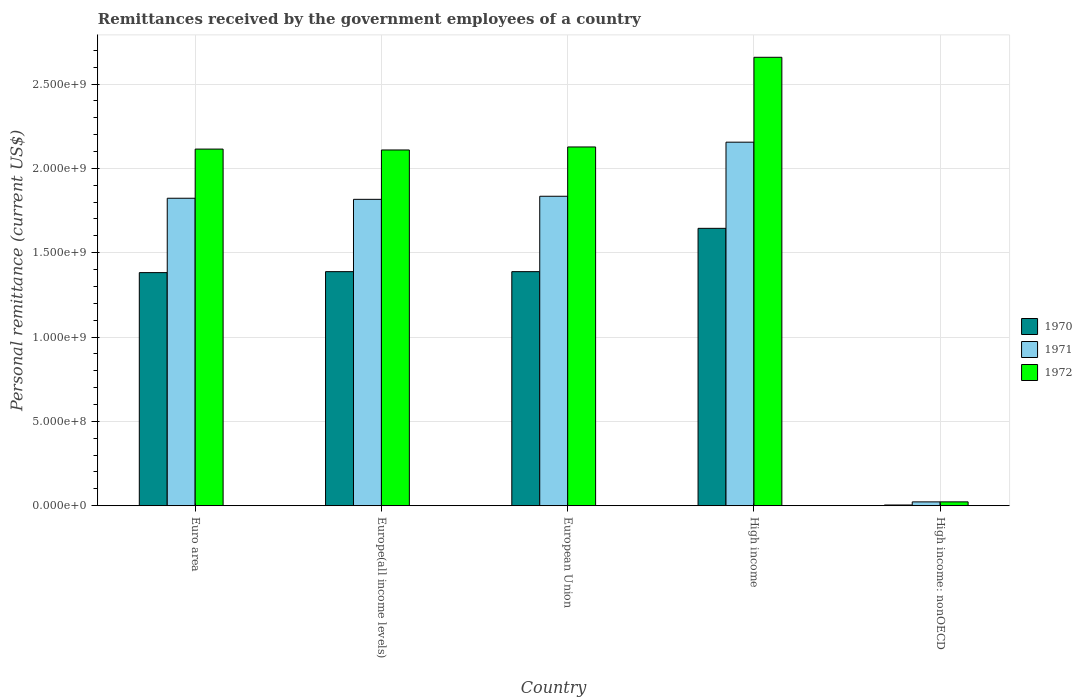How many different coloured bars are there?
Offer a very short reply. 3. How many groups of bars are there?
Your answer should be very brief. 5. Are the number of bars per tick equal to the number of legend labels?
Keep it short and to the point. Yes. How many bars are there on the 3rd tick from the left?
Make the answer very short. 3. How many bars are there on the 4th tick from the right?
Your response must be concise. 3. What is the label of the 2nd group of bars from the left?
Offer a terse response. Europe(all income levels). What is the remittances received by the government employees in 1970 in Euro area?
Provide a short and direct response. 1.38e+09. Across all countries, what is the maximum remittances received by the government employees in 1970?
Give a very brief answer. 1.64e+09. Across all countries, what is the minimum remittances received by the government employees in 1971?
Make the answer very short. 2.28e+07. In which country was the remittances received by the government employees in 1970 maximum?
Ensure brevity in your answer.  High income. In which country was the remittances received by the government employees in 1972 minimum?
Keep it short and to the point. High income: nonOECD. What is the total remittances received by the government employees in 1970 in the graph?
Your answer should be very brief. 5.81e+09. What is the difference between the remittances received by the government employees in 1970 in Europe(all income levels) and that in High income: nonOECD?
Give a very brief answer. 1.38e+09. What is the difference between the remittances received by the government employees in 1970 in High income and the remittances received by the government employees in 1972 in Euro area?
Your answer should be compact. -4.70e+08. What is the average remittances received by the government employees in 1971 per country?
Offer a terse response. 1.53e+09. What is the difference between the remittances received by the government employees of/in 1972 and remittances received by the government employees of/in 1971 in Euro area?
Your response must be concise. 2.91e+08. What is the ratio of the remittances received by the government employees in 1971 in Europe(all income levels) to that in High income: nonOECD?
Your response must be concise. 79.73. Is the difference between the remittances received by the government employees in 1972 in Euro area and European Union greater than the difference between the remittances received by the government employees in 1971 in Euro area and European Union?
Give a very brief answer. No. What is the difference between the highest and the second highest remittances received by the government employees in 1971?
Give a very brief answer. -1.17e+07. What is the difference between the highest and the lowest remittances received by the government employees in 1972?
Offer a terse response. 2.64e+09. In how many countries, is the remittances received by the government employees in 1970 greater than the average remittances received by the government employees in 1970 taken over all countries?
Make the answer very short. 4. Is the sum of the remittances received by the government employees in 1970 in European Union and High income: nonOECD greater than the maximum remittances received by the government employees in 1972 across all countries?
Give a very brief answer. No. Is it the case that in every country, the sum of the remittances received by the government employees in 1972 and remittances received by the government employees in 1971 is greater than the remittances received by the government employees in 1970?
Give a very brief answer. Yes. How many bars are there?
Provide a short and direct response. 15. Are all the bars in the graph horizontal?
Your response must be concise. No. Does the graph contain any zero values?
Provide a short and direct response. No. Where does the legend appear in the graph?
Make the answer very short. Center right. How many legend labels are there?
Your response must be concise. 3. What is the title of the graph?
Offer a very short reply. Remittances received by the government employees of a country. What is the label or title of the Y-axis?
Offer a very short reply. Personal remittance (current US$). What is the Personal remittance (current US$) in 1970 in Euro area?
Make the answer very short. 1.38e+09. What is the Personal remittance (current US$) in 1971 in Euro area?
Your answer should be very brief. 1.82e+09. What is the Personal remittance (current US$) in 1972 in Euro area?
Offer a very short reply. 2.11e+09. What is the Personal remittance (current US$) of 1970 in Europe(all income levels)?
Your response must be concise. 1.39e+09. What is the Personal remittance (current US$) in 1971 in Europe(all income levels)?
Ensure brevity in your answer.  1.82e+09. What is the Personal remittance (current US$) in 1972 in Europe(all income levels)?
Your response must be concise. 2.11e+09. What is the Personal remittance (current US$) in 1970 in European Union?
Your response must be concise. 1.39e+09. What is the Personal remittance (current US$) in 1971 in European Union?
Offer a terse response. 1.83e+09. What is the Personal remittance (current US$) in 1972 in European Union?
Make the answer very short. 2.13e+09. What is the Personal remittance (current US$) of 1970 in High income?
Ensure brevity in your answer.  1.64e+09. What is the Personal remittance (current US$) of 1971 in High income?
Offer a terse response. 2.16e+09. What is the Personal remittance (current US$) of 1972 in High income?
Offer a terse response. 2.66e+09. What is the Personal remittance (current US$) in 1970 in High income: nonOECD?
Provide a short and direct response. 4.40e+06. What is the Personal remittance (current US$) of 1971 in High income: nonOECD?
Your response must be concise. 2.28e+07. What is the Personal remittance (current US$) of 1972 in High income: nonOECD?
Provide a succinct answer. 2.29e+07. Across all countries, what is the maximum Personal remittance (current US$) of 1970?
Offer a terse response. 1.64e+09. Across all countries, what is the maximum Personal remittance (current US$) in 1971?
Offer a terse response. 2.16e+09. Across all countries, what is the maximum Personal remittance (current US$) of 1972?
Offer a terse response. 2.66e+09. Across all countries, what is the minimum Personal remittance (current US$) in 1970?
Ensure brevity in your answer.  4.40e+06. Across all countries, what is the minimum Personal remittance (current US$) in 1971?
Make the answer very short. 2.28e+07. Across all countries, what is the minimum Personal remittance (current US$) of 1972?
Give a very brief answer. 2.29e+07. What is the total Personal remittance (current US$) in 1970 in the graph?
Give a very brief answer. 5.81e+09. What is the total Personal remittance (current US$) of 1971 in the graph?
Ensure brevity in your answer.  7.65e+09. What is the total Personal remittance (current US$) in 1972 in the graph?
Provide a succinct answer. 9.03e+09. What is the difference between the Personal remittance (current US$) of 1970 in Euro area and that in Europe(all income levels)?
Offer a terse response. -5.80e+06. What is the difference between the Personal remittance (current US$) in 1971 in Euro area and that in Europe(all income levels)?
Make the answer very short. 6.47e+06. What is the difference between the Personal remittance (current US$) of 1972 in Euro area and that in Europe(all income levels)?
Give a very brief answer. 5.22e+06. What is the difference between the Personal remittance (current US$) of 1970 in Euro area and that in European Union?
Ensure brevity in your answer.  -5.80e+06. What is the difference between the Personal remittance (current US$) in 1971 in Euro area and that in European Union?
Your response must be concise. -1.17e+07. What is the difference between the Personal remittance (current US$) of 1972 in Euro area and that in European Union?
Ensure brevity in your answer.  -1.26e+07. What is the difference between the Personal remittance (current US$) in 1970 in Euro area and that in High income?
Keep it short and to the point. -2.63e+08. What is the difference between the Personal remittance (current US$) of 1971 in Euro area and that in High income?
Ensure brevity in your answer.  -3.32e+08. What is the difference between the Personal remittance (current US$) in 1972 in Euro area and that in High income?
Your answer should be compact. -5.44e+08. What is the difference between the Personal remittance (current US$) of 1970 in Euro area and that in High income: nonOECD?
Ensure brevity in your answer.  1.38e+09. What is the difference between the Personal remittance (current US$) of 1971 in Euro area and that in High income: nonOECD?
Offer a very short reply. 1.80e+09. What is the difference between the Personal remittance (current US$) in 1972 in Euro area and that in High income: nonOECD?
Keep it short and to the point. 2.09e+09. What is the difference between the Personal remittance (current US$) of 1970 in Europe(all income levels) and that in European Union?
Provide a succinct answer. 0. What is the difference between the Personal remittance (current US$) in 1971 in Europe(all income levels) and that in European Union?
Provide a short and direct response. -1.82e+07. What is the difference between the Personal remittance (current US$) of 1972 in Europe(all income levels) and that in European Union?
Keep it short and to the point. -1.78e+07. What is the difference between the Personal remittance (current US$) in 1970 in Europe(all income levels) and that in High income?
Your answer should be compact. -2.57e+08. What is the difference between the Personal remittance (current US$) in 1971 in Europe(all income levels) and that in High income?
Provide a succinct answer. -3.39e+08. What is the difference between the Personal remittance (current US$) of 1972 in Europe(all income levels) and that in High income?
Offer a very short reply. -5.49e+08. What is the difference between the Personal remittance (current US$) of 1970 in Europe(all income levels) and that in High income: nonOECD?
Your answer should be very brief. 1.38e+09. What is the difference between the Personal remittance (current US$) in 1971 in Europe(all income levels) and that in High income: nonOECD?
Offer a very short reply. 1.79e+09. What is the difference between the Personal remittance (current US$) of 1972 in Europe(all income levels) and that in High income: nonOECD?
Provide a succinct answer. 2.09e+09. What is the difference between the Personal remittance (current US$) of 1970 in European Union and that in High income?
Make the answer very short. -2.57e+08. What is the difference between the Personal remittance (current US$) of 1971 in European Union and that in High income?
Offer a very short reply. -3.21e+08. What is the difference between the Personal remittance (current US$) of 1972 in European Union and that in High income?
Offer a very short reply. -5.32e+08. What is the difference between the Personal remittance (current US$) in 1970 in European Union and that in High income: nonOECD?
Keep it short and to the point. 1.38e+09. What is the difference between the Personal remittance (current US$) of 1971 in European Union and that in High income: nonOECD?
Offer a terse response. 1.81e+09. What is the difference between the Personal remittance (current US$) of 1972 in European Union and that in High income: nonOECD?
Provide a succinct answer. 2.10e+09. What is the difference between the Personal remittance (current US$) in 1970 in High income and that in High income: nonOECD?
Give a very brief answer. 1.64e+09. What is the difference between the Personal remittance (current US$) of 1971 in High income and that in High income: nonOECD?
Offer a terse response. 2.13e+09. What is the difference between the Personal remittance (current US$) in 1972 in High income and that in High income: nonOECD?
Your answer should be compact. 2.64e+09. What is the difference between the Personal remittance (current US$) in 1970 in Euro area and the Personal remittance (current US$) in 1971 in Europe(all income levels)?
Offer a terse response. -4.35e+08. What is the difference between the Personal remittance (current US$) in 1970 in Euro area and the Personal remittance (current US$) in 1972 in Europe(all income levels)?
Your response must be concise. -7.27e+08. What is the difference between the Personal remittance (current US$) of 1971 in Euro area and the Personal remittance (current US$) of 1972 in Europe(all income levels)?
Your response must be concise. -2.86e+08. What is the difference between the Personal remittance (current US$) in 1970 in Euro area and the Personal remittance (current US$) in 1971 in European Union?
Your answer should be very brief. -4.53e+08. What is the difference between the Personal remittance (current US$) of 1970 in Euro area and the Personal remittance (current US$) of 1972 in European Union?
Ensure brevity in your answer.  -7.45e+08. What is the difference between the Personal remittance (current US$) in 1971 in Euro area and the Personal remittance (current US$) in 1972 in European Union?
Your response must be concise. -3.04e+08. What is the difference between the Personal remittance (current US$) in 1970 in Euro area and the Personal remittance (current US$) in 1971 in High income?
Your response must be concise. -7.73e+08. What is the difference between the Personal remittance (current US$) in 1970 in Euro area and the Personal remittance (current US$) in 1972 in High income?
Your response must be concise. -1.28e+09. What is the difference between the Personal remittance (current US$) in 1971 in Euro area and the Personal remittance (current US$) in 1972 in High income?
Provide a succinct answer. -8.36e+08. What is the difference between the Personal remittance (current US$) in 1970 in Euro area and the Personal remittance (current US$) in 1971 in High income: nonOECD?
Offer a terse response. 1.36e+09. What is the difference between the Personal remittance (current US$) in 1970 in Euro area and the Personal remittance (current US$) in 1972 in High income: nonOECD?
Keep it short and to the point. 1.36e+09. What is the difference between the Personal remittance (current US$) of 1971 in Euro area and the Personal remittance (current US$) of 1972 in High income: nonOECD?
Provide a succinct answer. 1.80e+09. What is the difference between the Personal remittance (current US$) of 1970 in Europe(all income levels) and the Personal remittance (current US$) of 1971 in European Union?
Offer a terse response. -4.47e+08. What is the difference between the Personal remittance (current US$) of 1970 in Europe(all income levels) and the Personal remittance (current US$) of 1972 in European Union?
Your answer should be compact. -7.39e+08. What is the difference between the Personal remittance (current US$) in 1971 in Europe(all income levels) and the Personal remittance (current US$) in 1972 in European Union?
Your response must be concise. -3.10e+08. What is the difference between the Personal remittance (current US$) in 1970 in Europe(all income levels) and the Personal remittance (current US$) in 1971 in High income?
Your response must be concise. -7.68e+08. What is the difference between the Personal remittance (current US$) of 1970 in Europe(all income levels) and the Personal remittance (current US$) of 1972 in High income?
Your answer should be compact. -1.27e+09. What is the difference between the Personal remittance (current US$) in 1971 in Europe(all income levels) and the Personal remittance (current US$) in 1972 in High income?
Provide a succinct answer. -8.42e+08. What is the difference between the Personal remittance (current US$) of 1970 in Europe(all income levels) and the Personal remittance (current US$) of 1971 in High income: nonOECD?
Ensure brevity in your answer.  1.37e+09. What is the difference between the Personal remittance (current US$) of 1970 in Europe(all income levels) and the Personal remittance (current US$) of 1972 in High income: nonOECD?
Make the answer very short. 1.36e+09. What is the difference between the Personal remittance (current US$) of 1971 in Europe(all income levels) and the Personal remittance (current US$) of 1972 in High income: nonOECD?
Provide a short and direct response. 1.79e+09. What is the difference between the Personal remittance (current US$) in 1970 in European Union and the Personal remittance (current US$) in 1971 in High income?
Offer a terse response. -7.68e+08. What is the difference between the Personal remittance (current US$) of 1970 in European Union and the Personal remittance (current US$) of 1972 in High income?
Provide a succinct answer. -1.27e+09. What is the difference between the Personal remittance (current US$) in 1971 in European Union and the Personal remittance (current US$) in 1972 in High income?
Provide a short and direct response. -8.24e+08. What is the difference between the Personal remittance (current US$) in 1970 in European Union and the Personal remittance (current US$) in 1971 in High income: nonOECD?
Your answer should be very brief. 1.37e+09. What is the difference between the Personal remittance (current US$) in 1970 in European Union and the Personal remittance (current US$) in 1972 in High income: nonOECD?
Ensure brevity in your answer.  1.36e+09. What is the difference between the Personal remittance (current US$) of 1971 in European Union and the Personal remittance (current US$) of 1972 in High income: nonOECD?
Your answer should be compact. 1.81e+09. What is the difference between the Personal remittance (current US$) of 1970 in High income and the Personal remittance (current US$) of 1971 in High income: nonOECD?
Make the answer very short. 1.62e+09. What is the difference between the Personal remittance (current US$) of 1970 in High income and the Personal remittance (current US$) of 1972 in High income: nonOECD?
Offer a terse response. 1.62e+09. What is the difference between the Personal remittance (current US$) in 1971 in High income and the Personal remittance (current US$) in 1972 in High income: nonOECD?
Your response must be concise. 2.13e+09. What is the average Personal remittance (current US$) of 1970 per country?
Give a very brief answer. 1.16e+09. What is the average Personal remittance (current US$) in 1971 per country?
Your answer should be very brief. 1.53e+09. What is the average Personal remittance (current US$) of 1972 per country?
Offer a very short reply. 1.81e+09. What is the difference between the Personal remittance (current US$) of 1970 and Personal remittance (current US$) of 1971 in Euro area?
Offer a very short reply. -4.41e+08. What is the difference between the Personal remittance (current US$) of 1970 and Personal remittance (current US$) of 1972 in Euro area?
Make the answer very short. -7.32e+08. What is the difference between the Personal remittance (current US$) of 1971 and Personal remittance (current US$) of 1972 in Euro area?
Offer a terse response. -2.91e+08. What is the difference between the Personal remittance (current US$) in 1970 and Personal remittance (current US$) in 1971 in Europe(all income levels)?
Your answer should be very brief. -4.29e+08. What is the difference between the Personal remittance (current US$) of 1970 and Personal remittance (current US$) of 1972 in Europe(all income levels)?
Your answer should be very brief. -7.21e+08. What is the difference between the Personal remittance (current US$) of 1971 and Personal remittance (current US$) of 1972 in Europe(all income levels)?
Your answer should be very brief. -2.93e+08. What is the difference between the Personal remittance (current US$) of 1970 and Personal remittance (current US$) of 1971 in European Union?
Your answer should be compact. -4.47e+08. What is the difference between the Personal remittance (current US$) of 1970 and Personal remittance (current US$) of 1972 in European Union?
Make the answer very short. -7.39e+08. What is the difference between the Personal remittance (current US$) in 1971 and Personal remittance (current US$) in 1972 in European Union?
Ensure brevity in your answer.  -2.92e+08. What is the difference between the Personal remittance (current US$) of 1970 and Personal remittance (current US$) of 1971 in High income?
Give a very brief answer. -5.11e+08. What is the difference between the Personal remittance (current US$) in 1970 and Personal remittance (current US$) in 1972 in High income?
Ensure brevity in your answer.  -1.01e+09. What is the difference between the Personal remittance (current US$) of 1971 and Personal remittance (current US$) of 1972 in High income?
Ensure brevity in your answer.  -5.03e+08. What is the difference between the Personal remittance (current US$) of 1970 and Personal remittance (current US$) of 1971 in High income: nonOECD?
Provide a succinct answer. -1.84e+07. What is the difference between the Personal remittance (current US$) of 1970 and Personal remittance (current US$) of 1972 in High income: nonOECD?
Give a very brief answer. -1.85e+07. What is the difference between the Personal remittance (current US$) in 1971 and Personal remittance (current US$) in 1972 in High income: nonOECD?
Offer a very short reply. -1.37e+05. What is the ratio of the Personal remittance (current US$) of 1972 in Euro area to that in Europe(all income levels)?
Keep it short and to the point. 1. What is the ratio of the Personal remittance (current US$) in 1970 in Euro area to that in High income?
Your answer should be very brief. 0.84. What is the ratio of the Personal remittance (current US$) of 1971 in Euro area to that in High income?
Your answer should be very brief. 0.85. What is the ratio of the Personal remittance (current US$) of 1972 in Euro area to that in High income?
Give a very brief answer. 0.8. What is the ratio of the Personal remittance (current US$) in 1970 in Euro area to that in High income: nonOECD?
Keep it short and to the point. 314.09. What is the ratio of the Personal remittance (current US$) in 1971 in Euro area to that in High income: nonOECD?
Give a very brief answer. 80.01. What is the ratio of the Personal remittance (current US$) of 1972 in Euro area to that in High income: nonOECD?
Provide a short and direct response. 92.24. What is the ratio of the Personal remittance (current US$) of 1972 in Europe(all income levels) to that in European Union?
Offer a very short reply. 0.99. What is the ratio of the Personal remittance (current US$) of 1970 in Europe(all income levels) to that in High income?
Offer a very short reply. 0.84. What is the ratio of the Personal remittance (current US$) in 1971 in Europe(all income levels) to that in High income?
Your answer should be compact. 0.84. What is the ratio of the Personal remittance (current US$) of 1972 in Europe(all income levels) to that in High income?
Offer a very short reply. 0.79. What is the ratio of the Personal remittance (current US$) in 1970 in Europe(all income levels) to that in High income: nonOECD?
Offer a very short reply. 315.41. What is the ratio of the Personal remittance (current US$) of 1971 in Europe(all income levels) to that in High income: nonOECD?
Offer a terse response. 79.73. What is the ratio of the Personal remittance (current US$) of 1972 in Europe(all income levels) to that in High income: nonOECD?
Offer a very short reply. 92.02. What is the ratio of the Personal remittance (current US$) in 1970 in European Union to that in High income?
Make the answer very short. 0.84. What is the ratio of the Personal remittance (current US$) in 1971 in European Union to that in High income?
Give a very brief answer. 0.85. What is the ratio of the Personal remittance (current US$) in 1970 in European Union to that in High income: nonOECD?
Your response must be concise. 315.41. What is the ratio of the Personal remittance (current US$) in 1971 in European Union to that in High income: nonOECD?
Make the answer very short. 80.52. What is the ratio of the Personal remittance (current US$) in 1972 in European Union to that in High income: nonOECD?
Offer a terse response. 92.79. What is the ratio of the Personal remittance (current US$) in 1970 in High income to that in High income: nonOECD?
Offer a very short reply. 373.75. What is the ratio of the Personal remittance (current US$) of 1971 in High income to that in High income: nonOECD?
Offer a very short reply. 94.6. What is the ratio of the Personal remittance (current US$) of 1972 in High income to that in High income: nonOECD?
Keep it short and to the point. 115.99. What is the difference between the highest and the second highest Personal remittance (current US$) of 1970?
Your response must be concise. 2.57e+08. What is the difference between the highest and the second highest Personal remittance (current US$) in 1971?
Offer a very short reply. 3.21e+08. What is the difference between the highest and the second highest Personal remittance (current US$) of 1972?
Provide a succinct answer. 5.32e+08. What is the difference between the highest and the lowest Personal remittance (current US$) of 1970?
Your response must be concise. 1.64e+09. What is the difference between the highest and the lowest Personal remittance (current US$) of 1971?
Your answer should be very brief. 2.13e+09. What is the difference between the highest and the lowest Personal remittance (current US$) of 1972?
Your answer should be very brief. 2.64e+09. 